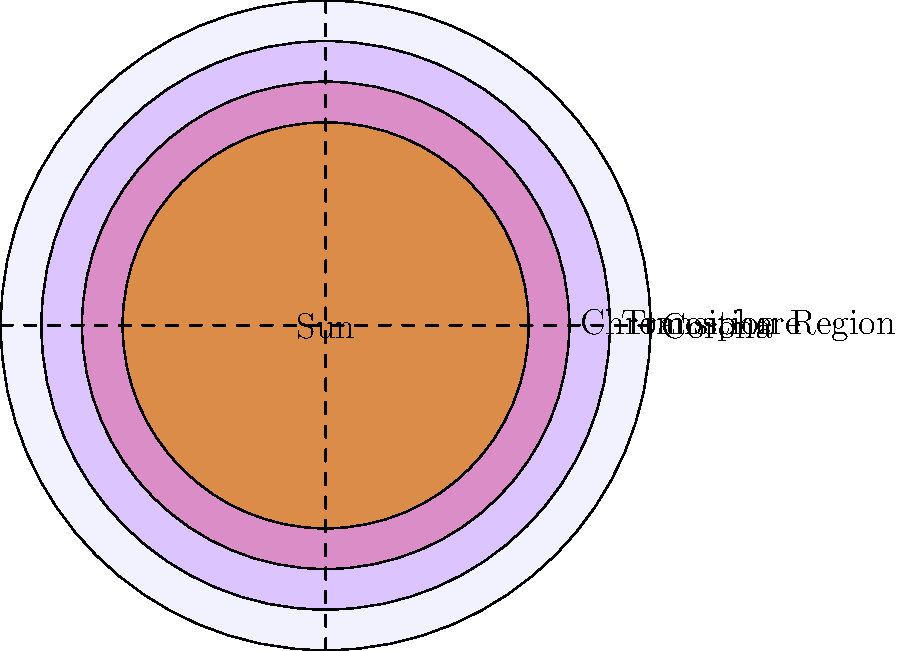In this cross-sectional diagram of the Sun's atmosphere, which layer is known for its sudden temperature increase and is often compared to the "turnabout" moments in Phoenix Wright: Ace Attorney cases? Let's break this down step-by-step:

1. The Sun's atmosphere consists of several layers, each with distinct characteristics.

2. From the innermost to the outermost layer, we have:
   a) Photosphere (visible surface of the Sun)
   b) Chromosphere
   c) Transition Region
   d) Corona

3. The Transition Region, situated between the Chromosphere and Corona, is known for its sudden and dramatic temperature increase.

4. This temperature jump is from about 10,000 K in the Chromosphere to nearly 1,000,000 K in the Corona.

5. This abrupt change can be likened to the "turnabout" moments in Phoenix Wright: Ace Attorney, where the case suddenly takes an unexpected turn, much like how the temperature unexpectedly spikes in this region.

6. Just as a turnabout in Phoenix Wright often leads to a breakthrough in the case, the Transition Region marks a crucial shift in the Sun's atmosphere, leading to the extremely hot Corona.

Therefore, the layer that best fits the description in the question is the Transition Region.
Answer: Transition Region 